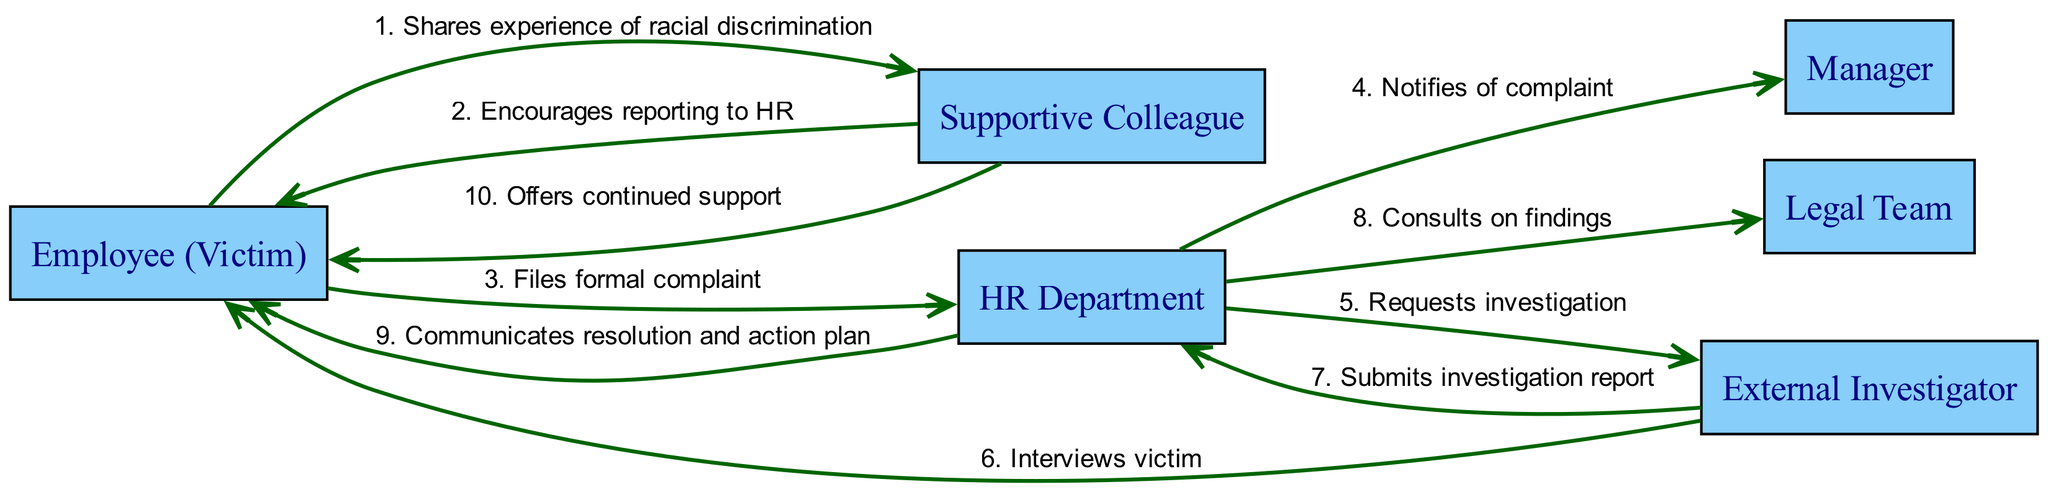What is the first action taken in the reporting process? The first action in the sequence is the Employee (Victim) sharing their experience of racial discrimination with the Supportive Colleague. This is derived from the first message in the sequence listed in the diagram.
Answer: Shares experience of racial discrimination How many nodes are present in the diagram? The diagram has six distinct actors or nodes, which are Employee (Victim), Supportive Colleague, HR Department, Manager, Legal Team, and External Investigator. This count helps understand the key roles involved in the process.
Answer: Six Which actor is responsible for interviewing the victim? The External Investigator is responsible for interviewing the Employee (Victim). This is evident from the specific message in the diagram that directly links the investigator to the victim.
Answer: External Investigator What action follows after the External Investigator submits the report? After the External Investigator submits the investigation report to the HR Department, the HR Department then consults the Legal Team regarding the findings, as per the sequence flow depicted in the diagram.
Answer: Consults on findings Which two actors are involved in the final communication of resolution? The two actors involved in the final communication of resolution are the HR Department and the Employee (Victim). The sequence shows the HR Department informing the victim of the resolution and action plan.
Answer: HR Department and Employee (Victim) What type of support does the Supportive Colleague offer after the resolution? The Supportive Colleague offers continued support to the Employee (Victim) after the resolution is communicated. This is a conclusive action that reinforces the colleague's supportive role throughout the process.
Answer: Offers continued support 